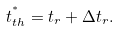<formula> <loc_0><loc_0><loc_500><loc_500>t ^ { ^ { * } } _ { t h } = t _ { r } + \Delta t _ { r } .</formula> 